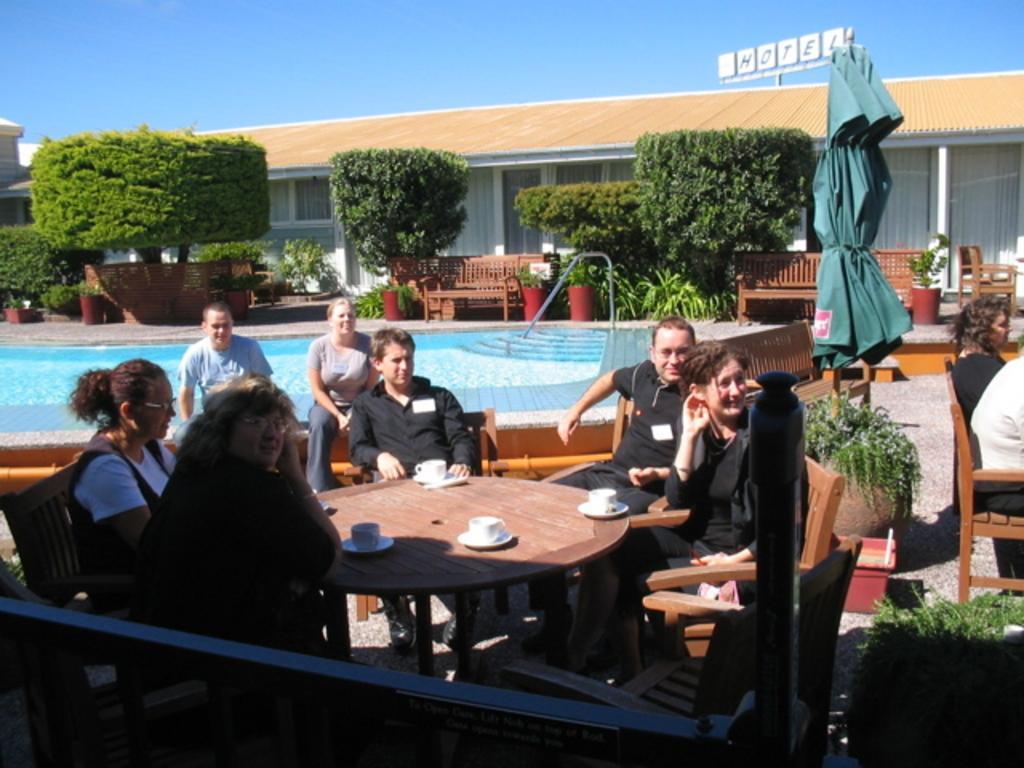Can you describe this image briefly? There are group of people sitting on chairs and there is a table in front of them which has cups on it and there is a swimming pool beside them and there are trees,chairs and a building in the background. 